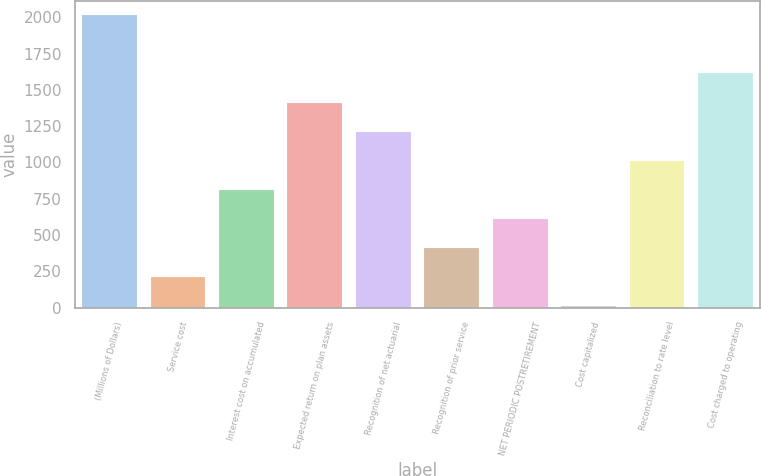Convert chart to OTSL. <chart><loc_0><loc_0><loc_500><loc_500><bar_chart><fcel>(Millions of Dollars)<fcel>Service cost<fcel>Interest cost on accumulated<fcel>Expected return on plan assets<fcel>Recognition of net actuarial<fcel>Recognition of prior service<fcel>NET PERIODIC POSTRETIREMENT<fcel>Cost capitalized<fcel>Reconciliation to rate level<fcel>Cost charged to operating<nl><fcel>2013<fcel>212.1<fcel>812.4<fcel>1412.7<fcel>1212.6<fcel>412.2<fcel>612.3<fcel>12<fcel>1012.5<fcel>1612.8<nl></chart> 